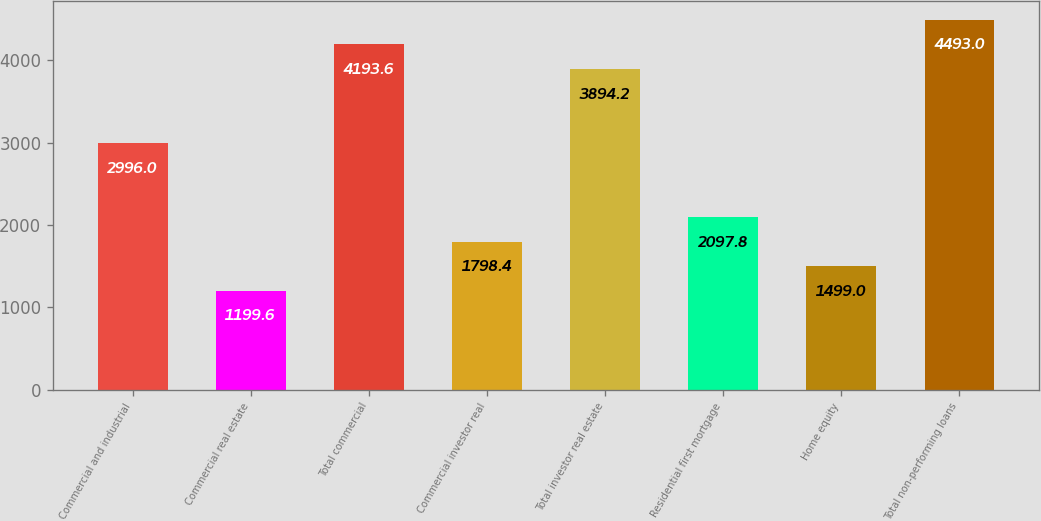Convert chart to OTSL. <chart><loc_0><loc_0><loc_500><loc_500><bar_chart><fcel>Commercial and industrial<fcel>Commercial real estate<fcel>Total commercial<fcel>Commercial investor real<fcel>Total investor real estate<fcel>Residential first mortgage<fcel>Home equity<fcel>Total non-performing loans<nl><fcel>2996<fcel>1199.6<fcel>4193.6<fcel>1798.4<fcel>3894.2<fcel>2097.8<fcel>1499<fcel>4493<nl></chart> 